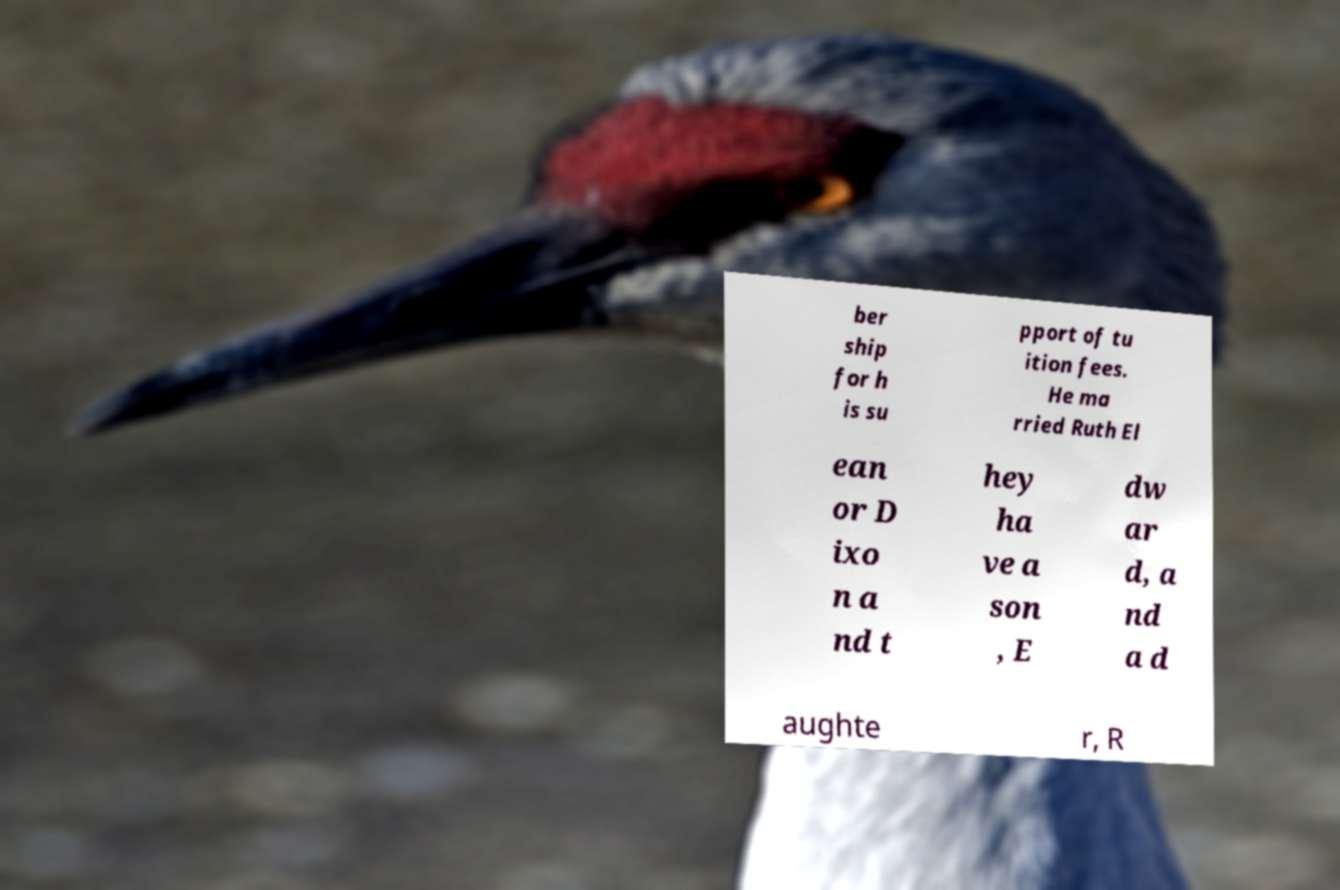I need the written content from this picture converted into text. Can you do that? ber ship for h is su pport of tu ition fees. He ma rried Ruth El ean or D ixo n a nd t hey ha ve a son , E dw ar d, a nd a d aughte r, R 